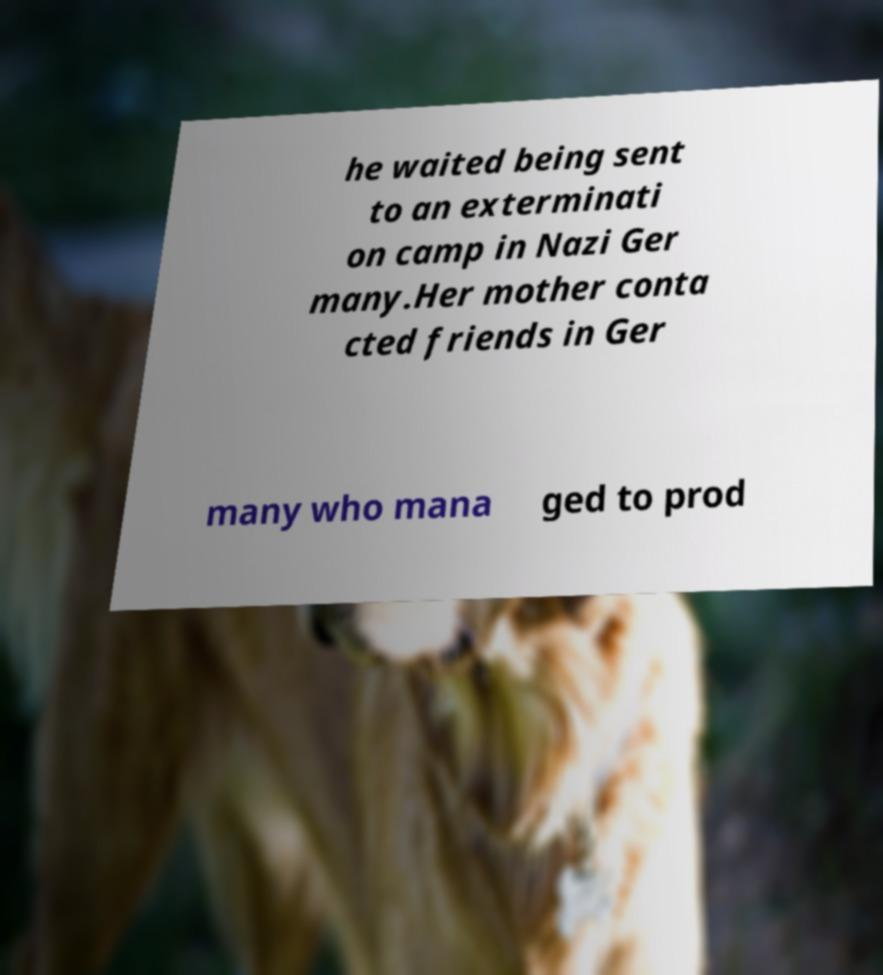Please read and relay the text visible in this image. What does it say? he waited being sent to an exterminati on camp in Nazi Ger many.Her mother conta cted friends in Ger many who mana ged to prod 